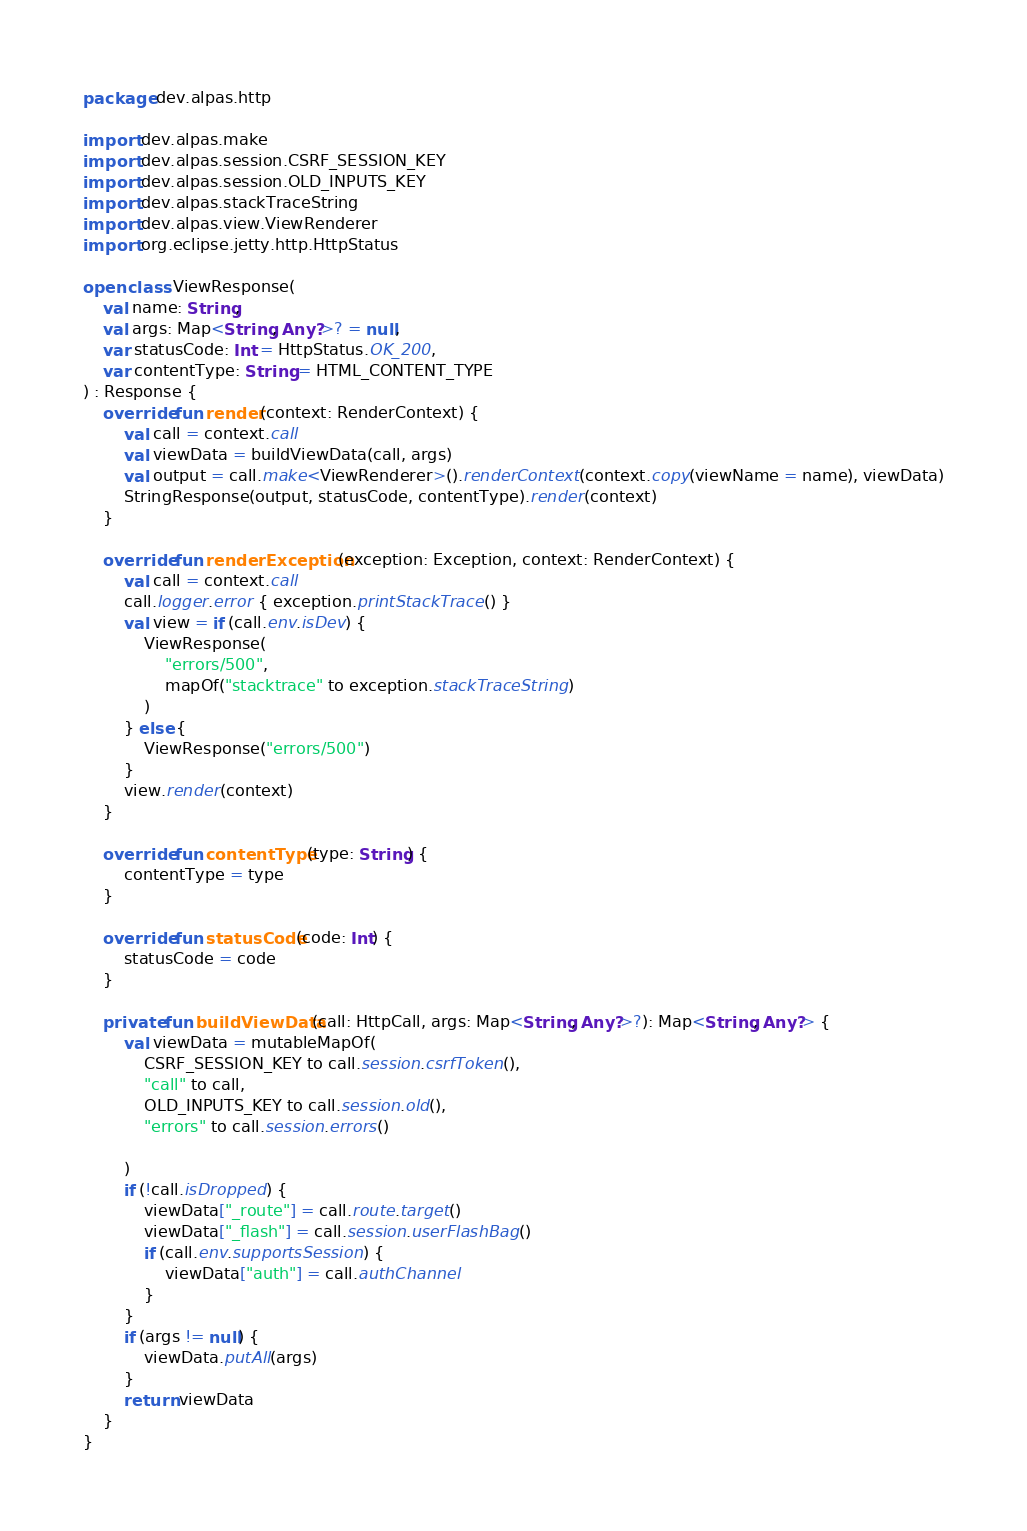<code> <loc_0><loc_0><loc_500><loc_500><_Kotlin_>package dev.alpas.http

import dev.alpas.make
import dev.alpas.session.CSRF_SESSION_KEY
import dev.alpas.session.OLD_INPUTS_KEY
import dev.alpas.stackTraceString
import dev.alpas.view.ViewRenderer
import org.eclipse.jetty.http.HttpStatus

open class ViewResponse(
    val name: String,
    val args: Map<String, Any?>? = null,
    var statusCode: Int = HttpStatus.OK_200,
    var contentType: String = HTML_CONTENT_TYPE
) : Response {
    override fun render(context: RenderContext) {
        val call = context.call
        val viewData = buildViewData(call, args)
        val output = call.make<ViewRenderer>().renderContext(context.copy(viewName = name), viewData)
        StringResponse(output, statusCode, contentType).render(context)
    }

    override fun renderException(exception: Exception, context: RenderContext) {
        val call = context.call
        call.logger.error { exception.printStackTrace() }
        val view = if (call.env.isDev) {
            ViewResponse(
                "errors/500",
                mapOf("stacktrace" to exception.stackTraceString)
            )
        } else {
            ViewResponse("errors/500")
        }
        view.render(context)
    }

    override fun contentType(type: String) {
        contentType = type
    }

    override fun statusCode(code: Int) {
        statusCode = code
    }

    private fun buildViewData(call: HttpCall, args: Map<String, Any?>?): Map<String, Any?> {
        val viewData = mutableMapOf(
            CSRF_SESSION_KEY to call.session.csrfToken(),
            "call" to call,
            OLD_INPUTS_KEY to call.session.old(),
            "errors" to call.session.errors()

        )
        if (!call.isDropped) {
            viewData["_route"] = call.route.target()
            viewData["_flash"] = call.session.userFlashBag()
            if (call.env.supportsSession) {
                viewData["auth"] = call.authChannel
            }
        }
        if (args != null) {
            viewData.putAll(args)
        }
        return viewData
    }
}
</code> 